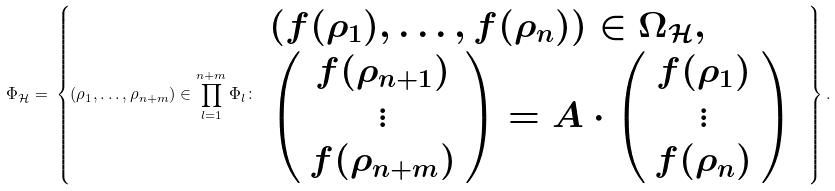<formula> <loc_0><loc_0><loc_500><loc_500>\Phi _ { \mathcal { H } } = \, \left \{ ( \rho _ { 1 } , \dots , \rho _ { n + m } ) \in \prod _ { l = 1 } ^ { n + m } \Phi _ { l } \colon \, \begin{array} { l } \left ( f ( \rho _ { 1 } ) , \dots , f ( \rho _ { n } ) \right ) \in \Omega _ { \mathcal { H } } , \\ \left ( \begin{array} { c } f ( \rho _ { n + 1 } ) \\ \vdots \\ f ( \rho _ { n + m } ) \end{array} \right ) = A \cdot \left ( \begin{array} { c } f ( \rho _ { 1 } ) \\ \vdots \\ f ( \rho _ { n } ) \end{array} \right ) \, \end{array} \right \} .</formula> 